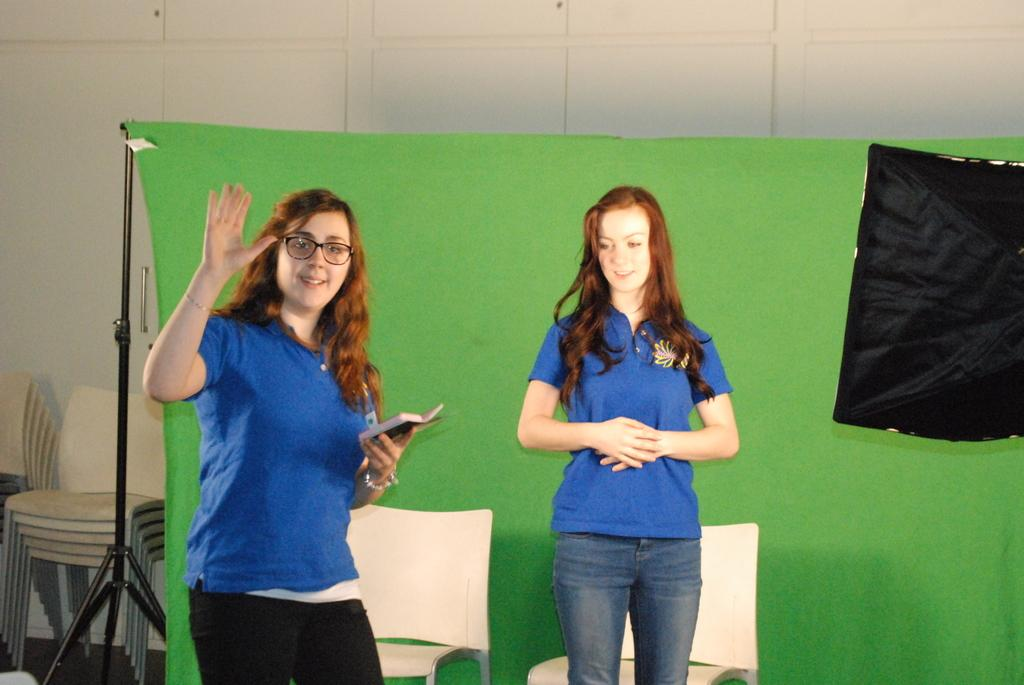How many people are present in the image? There are two people standing in the image. What can be seen in the background of the image? There are chairs, banners, and wooden cupboards in the background of the image. What type of wren is sitting on the chair in the image? There is no wren present in the image; it features two people and objects in the background. 